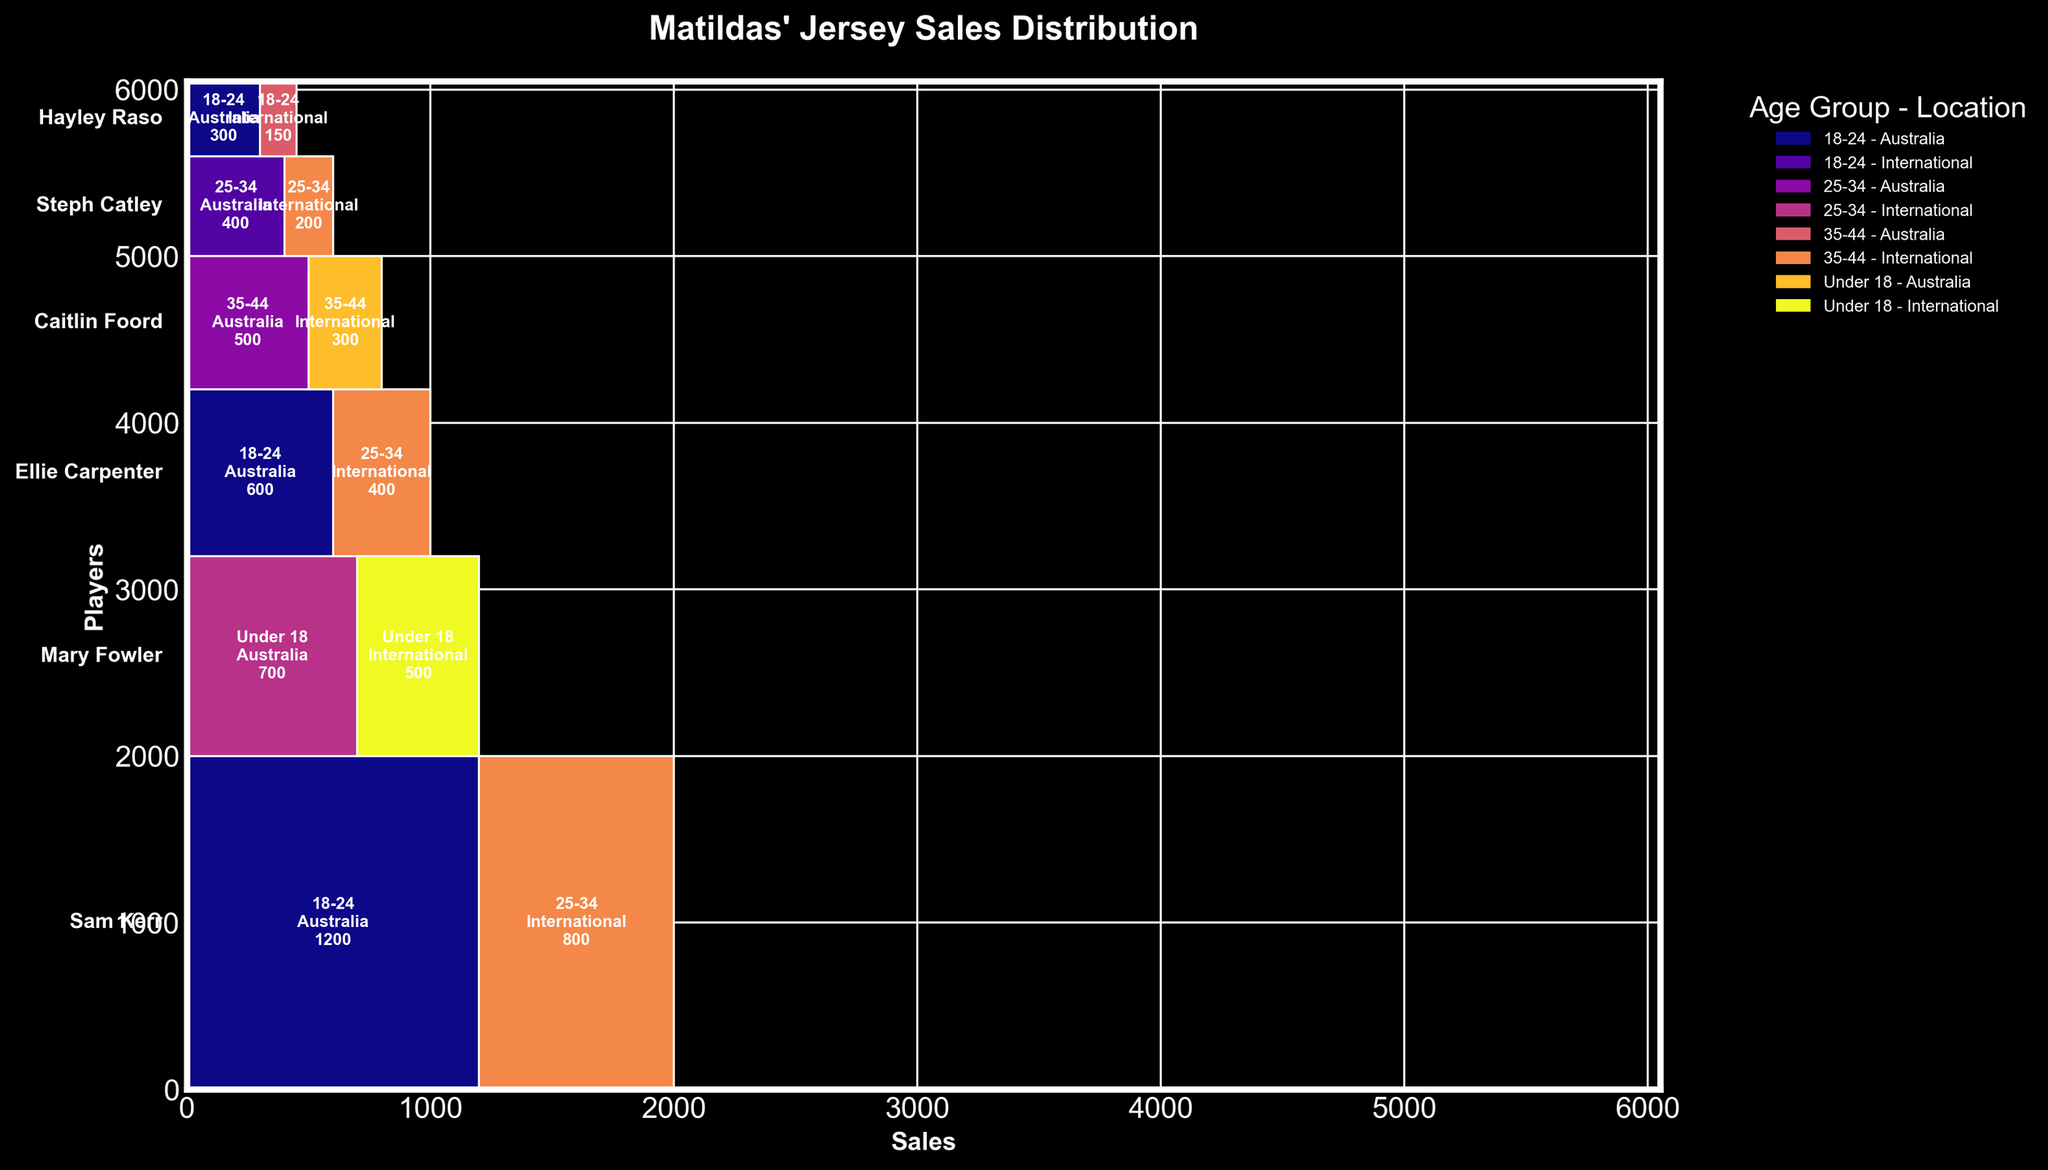What's the title of the mosaic plot? The title of the mosaic plot is usually displayed at the top of the plot. This indicates the subject of the data being represented.
Answer: Matildas' Jersey Sales Distribution Which player has the highest total jersey sales? To find which player has the highest total jersey sales, look at the height of the bars representing each player in the mosaic plot. The player with the tallest bar is the one with the highest sales.
Answer: Sam Kerr How many age groups are represented in the plot? The different age groups are identified by distinct colors or clusters within each player's section. Count the different age ranges displayed in the legend or within the plot.
Answer: 4 What's the combined sales of Sam Kerr from both Australia and International locations for age group 18-24? Evaluate the segments corresponding to 18-24 age group for both locations (Australia and International) within Sam Kerr’s section. Sum up the sales for these segments. 1200 (Australia) + 800 (International) = 2000.
Answer: 2000 Which age group from Australia has the highest sales for any player? Compare the sales figures for the different age groups from Australia for each player shown in the plot. Find the one with the highest value.
Answer: 18-24 for Sam Kerr Whose jerseys are more popular internationally with the 25-34 age group, Sam Kerr or Ellie Carpenter? Look at the segments representing international sales for the 25-34 age group for both Sam Kerr and Ellie Carpenter. Compare the values. Sam Kerr has 800, while Ellie Carpenter has 400.
Answer: Sam Kerr What is the sales difference between Caitlin Foord’s jerseys in Australia and International for the 35-44 age group? Locate the segments for Caitlin Foord in the 35-44 age group for both Australia and International. Calculate the difference: 500 (Australia) - 300 (International) = 200.
Answer: 200 Which player has the smallest total sales? To determine the player with the smallest total sales, look at the player with the shortest bar representing their total sales in the plot.
Answer: Hayley Raso How does the sales for Steph Catley in Australia (25-34 age group) compare to those for Ellie Carpenter in the same demographic? Compare the segments for Steph Catley and Ellie Carpenter representing the 25-34 age group from Australia. Steph Catley has 400, whereas Ellie Carpenter has 600.
Answer: Ellie Carpenter has higher sales 